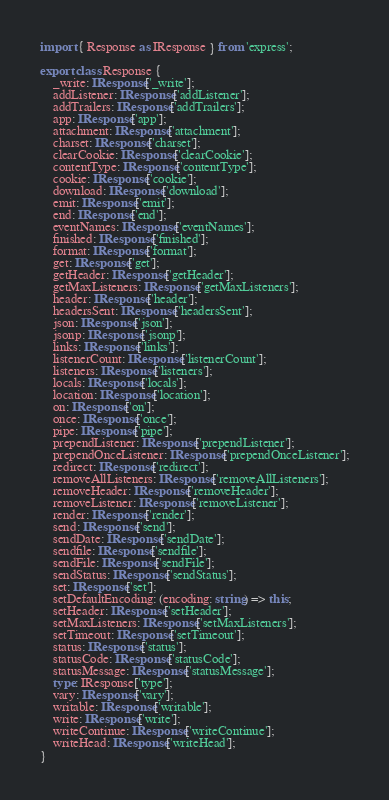Convert code to text. <code><loc_0><loc_0><loc_500><loc_500><_TypeScript_>import { Response as IResponse } from 'express';

export class Response {
    _write: IResponse['_write'];
    addListener: IResponse['addListener'];
    addTrailers: IResponse['addTrailers'];
    app: IResponse['app'];
    attachment: IResponse['attachment'];
    charset: IResponse['charset'];
    clearCookie: IResponse['clearCookie'];
    contentType: IResponse['contentType'];
    cookie: IResponse['cookie'];
    download: IResponse['download'];
    emit: IResponse['emit'];
    end: IResponse['end'];
    eventNames: IResponse['eventNames'];
    finished: IResponse['finished'];
    format: IResponse['format'];
    get: IResponse['get'];
    getHeader: IResponse['getHeader'];
    getMaxListeners: IResponse['getMaxListeners'];
    header: IResponse['header'];
    headersSent: IResponse['headersSent'];
    json: IResponse['json'];
    jsonp: IResponse['jsonp'];
    links: IResponse['links'];
    listenerCount: IResponse['listenerCount'];
    listeners: IResponse['listeners'];
    locals: IResponse['locals'];
    location: IResponse['location'];
    on: IResponse['on'];
    once: IResponse['once'];
    pipe: IResponse['pipe'];
    prependListener: IResponse['prependListener'];
    prependOnceListener: IResponse['prependOnceListener'];
    redirect: IResponse['redirect'];
    removeAllListeners: IResponse['removeAllListeners'];
    removeHeader: IResponse['removeHeader'];
    removeListener: IResponse['removeListener'];
    render: IResponse['render'];
    send: IResponse['send'];
    sendDate: IResponse['sendDate'];
    sendfile: IResponse['sendfile'];
    sendFile: IResponse['sendFile'];
    sendStatus: IResponse['sendStatus'];
    set: IResponse['set'];
    setDefaultEncoding: (encoding: string) => this;
    setHeader: IResponse['setHeader'];
    setMaxListeners: IResponse['setMaxListeners'];
    setTimeout: IResponse['setTimeout'];
    status: IResponse['status'];
    statusCode: IResponse['statusCode'];
    statusMessage: IResponse['statusMessage'];
    type: IResponse['type'];
    vary: IResponse['vary'];
    writable: IResponse['writable'];
    write: IResponse['write'];
    writeContinue: IResponse['writeContinue'];
    writeHead: IResponse['writeHead'];
}
</code> 